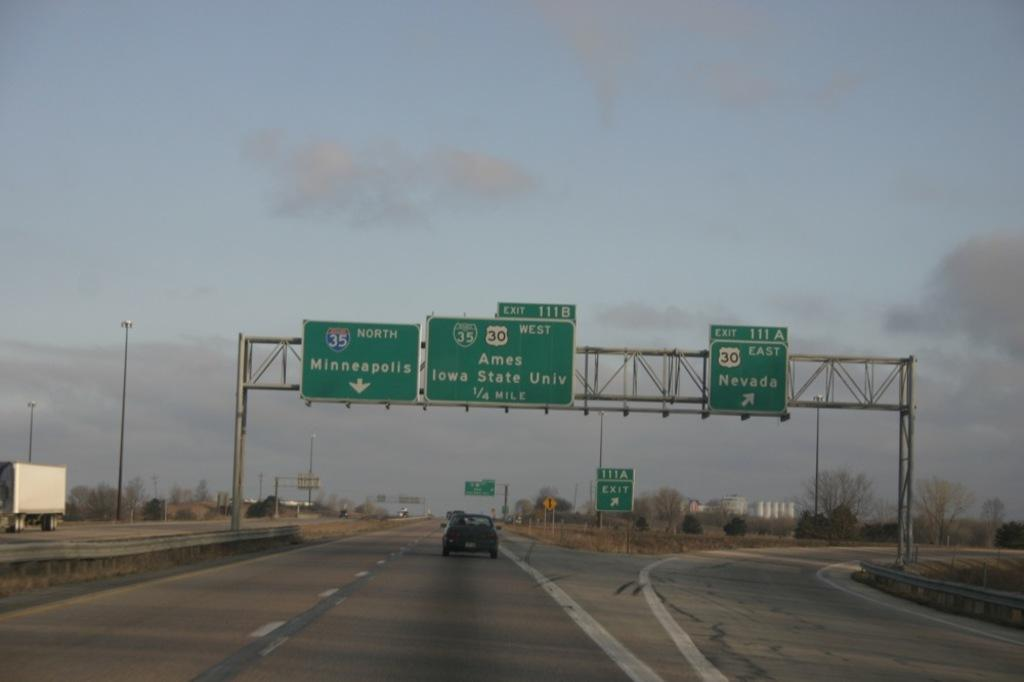Provide a one-sentence caption for the provided image. A freeway with one car passing under the signs 35  North Minneapolis, 35 30 West Ames Iowa State Univ 1/2 mile. 